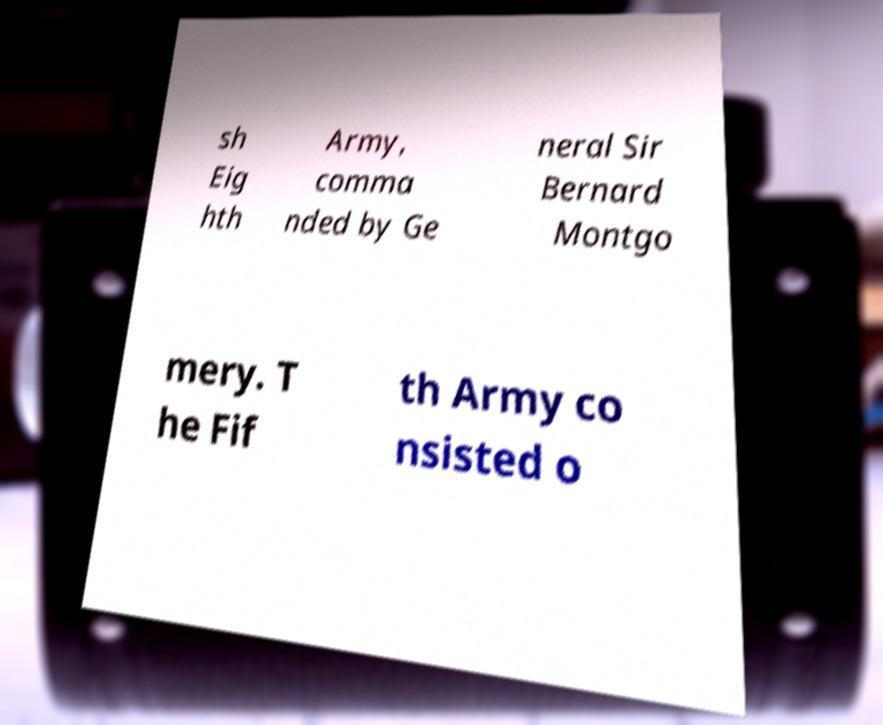Could you extract and type out the text from this image? sh Eig hth Army, comma nded by Ge neral Sir Bernard Montgo mery. T he Fif th Army co nsisted o 